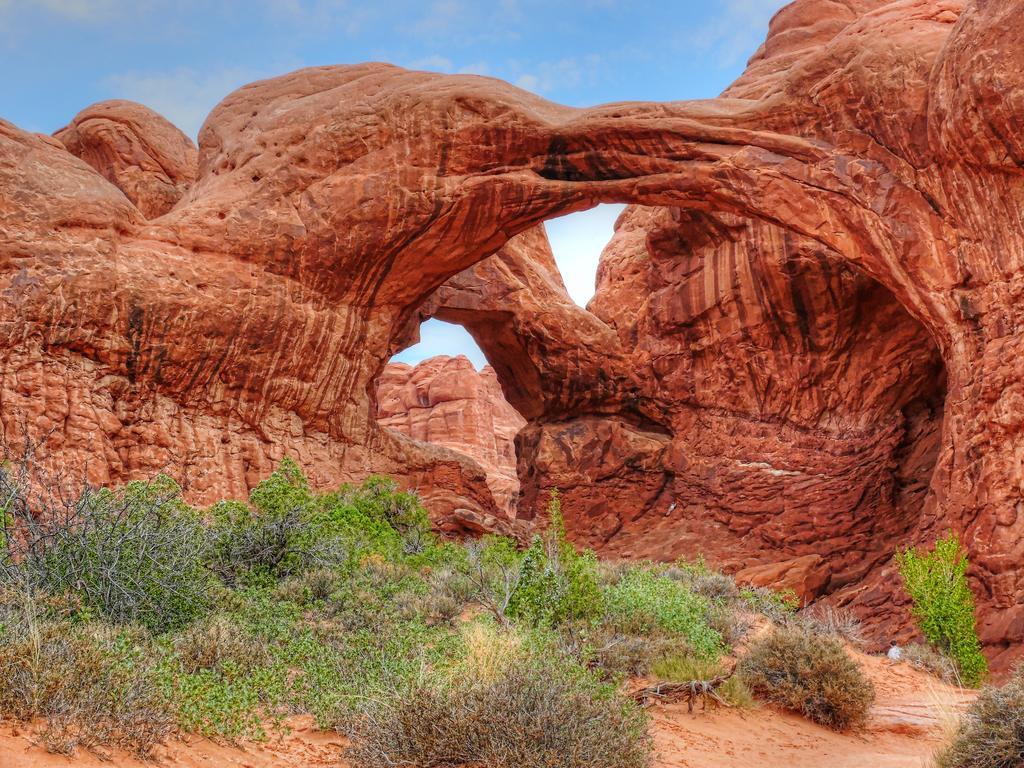Describe this image in one or two sentences. In this image in the center there are some mountains and at the bottom there is grass and sand, on the top of the image there is sky. 